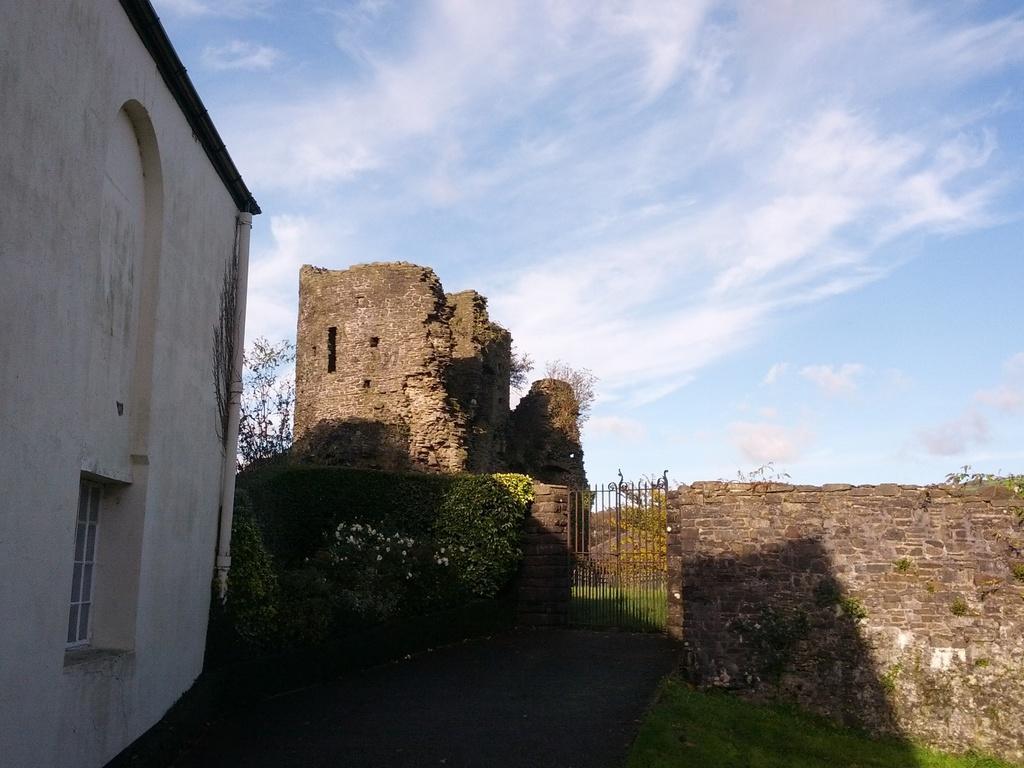How would you summarize this image in a sentence or two? In this image we can see buildings, creeper plants, grills, trees and sky with clouds in the background. 